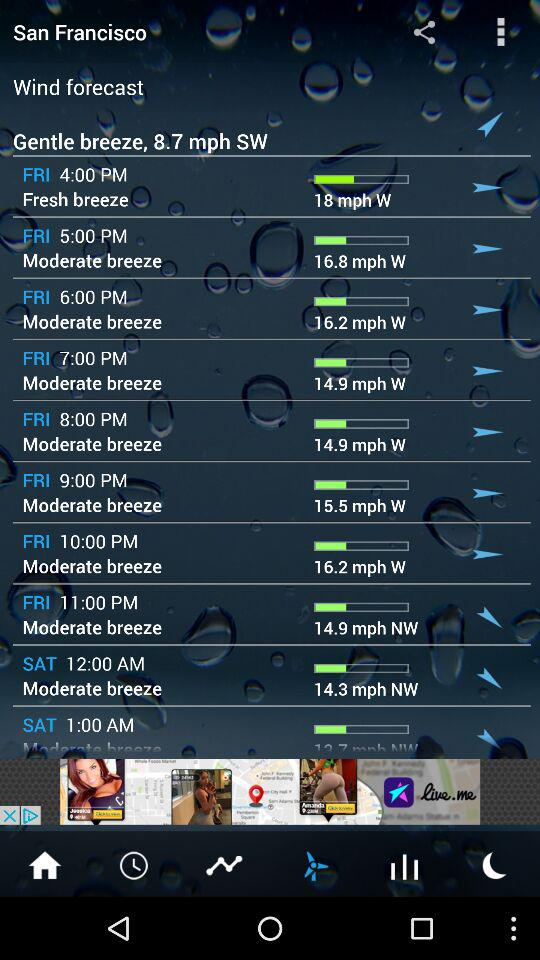What is the wind speed at 11 p.m. on Friday? The wind speed at 11 p.m. on Friday is 14.9 mph. 